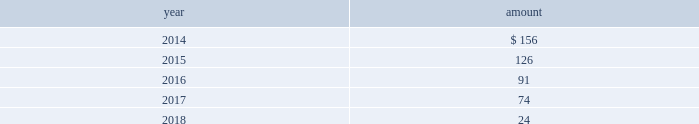The impairment tests performed for intangible assets as of july 31 , 2013 , 2012 and 2011 indicated no impairment charges were required .
Estimated amortization expense for finite-lived intangible assets for each of the five succeeding years is as follows : ( in millions ) .
Indefinite-lived acquired management contracts in july 2013 , in connection with the credit suisse etf transaction , the company acquired $ 231 million of indefinite-lived management contracts .
In march 2012 , in connection with the claymore transaction , the company acquired $ 163 million of indefinite-lived etp management contracts .
Finite-lived acquired management contracts in october 2013 , in connection with the mgpa transaction , the company acquired $ 29 million of finite-lived management contracts with a weighted-average estimated useful life of approximately eight years .
In september 2012 , in connection with the srpep transaction , the company acquired $ 40 million of finite- lived management contracts with a weighted-average estimated useful life of approximately 10 years .
11 .
Other assets at march 31 , 2013 , blackrock held an approximately one- third economic equity interest in private national mortgage acceptance company , llc ( 201cpnmac 201d ) , which is accounted for as an equity method investment and is included in other assets on the consolidated statements of financial condition .
On may 8 , 2013 , pennymac became the sole managing member of pnmac in connection with an initial public offering of pennymac ( the 201cpennymac ipo 201d ) .
As a result of the pennymac ipo , blackrock recorded a noncash , nonoperating pre-tax gain of $ 39 million related to the carrying value of its equity method investment .
Subsequent to the pennymac ipo , the company contributed 6.1 million units of its investment to a new donor advised fund ( the 201ccharitable contribution 201d ) .
The fair value of the charitable contribution was $ 124 million and is included in general and administration expenses on the consolidated statements of income .
In connection with the charitable contribution , the company also recorded a noncash , nonoperating pre-tax gain of $ 80 million related to the contributed investment and a tax benefit of approximately $ 48 million .
The carrying value and fair value of the company 2019s remaining interest ( approximately 20% ( 20 % ) or 16 million shares and units ) was approximately $ 127 million and $ 273 million , respectively , at december 31 , 2013 .
The fair value of the company 2019s interest reflected the pennymac stock price at december 31 , 2013 ( level 1 input ) .
12 .
Borrowings short-term borrowings the carrying value of short-term borrowings at december 31 , 2012 included $ 100 million under the 2012 revolving credit facility .
2013 revolving credit facility .
In march 2011 , the company entered into a five-year $ 3.5 billion unsecured revolving credit facility ( the 201c2011 credit facility 201d ) .
In march 2012 , the 2011 credit facility was amended to extend the maturity date by one year to march 2017 and in april 2012 the amount of the aggregate commitment was increased to $ 3.785 billion ( the 201c2012 credit facility 201d ) .
In march 2013 , the company 2019s credit facility was amended to extend the maturity date by one year to march 2018 and the amount of the aggregate commitment was increased to $ 3.990 billion ( the 201c2013 credit facility 201d ) .
The 2013 credit facility permits the company to request up to an additional $ 1.0 billion of borrowing capacity , subject to lender credit approval , increasing the overall size of the 2013 credit facility to an aggregate principal amount not to exceed $ 4.990 billion .
Interest on borrowings outstanding accrues at a rate based on the applicable london interbank offered rate plus a spread .
The 2013 credit facility requires the company not to exceed a maximum leverage ratio ( ratio of net debt to earnings before interest , taxes , depreciation and amortization , where net debt equals total debt less unrestricted cash ) of 3 to 1 , which was satisfied with a ratio of less than 1 to 1 at december 31 , 2013 .
The 2013 credit facility provides back- up liquidity , funds ongoing working capital for general corporate purposes and funds various investment opportunities .
At december 31 , 2013 , the company had no amount outstanding under the 2013 credit facility .
Commercial paper program .
On october 14 , 2009 , blackrock established a commercial paper program ( the 201ccp program 201d ) under which the company could issue unsecured commercial paper notes ( the 201ccp notes 201d ) on a private placement basis up to a maximum aggregate amount outstanding at any time of $ 3.0 billion .
On may 13 , 2011 , blackrock increased the maximum aggregate amount that may be borrowed under the cp program to $ 3.5 billion .
On may 17 , 2012 , blackrock increased the maximum aggregate amount to $ 3.785 billion .
In april 2013 , blackrock increased the maximum aggregate amount for which the company could issue unsecured cp notes on a private-placement basis up to a maximum aggregate amount outstanding at any time of $ 3.990 billion .
The commercial paper program is currently supported by the 2013 credit facility .
At december 31 , 2013 and 2012 , blackrock had no cp notes outstanding. .
What is the percent change in estimated amortization expense for finite-lived intangible assets from 2014 to 2015? 
Computations: ((156 - 126) / 126)
Answer: 0.2381. The impairment tests performed for intangible assets as of july 31 , 2013 , 2012 and 2011 indicated no impairment charges were required .
Estimated amortization expense for finite-lived intangible assets for each of the five succeeding years is as follows : ( in millions ) .
Indefinite-lived acquired management contracts in july 2013 , in connection with the credit suisse etf transaction , the company acquired $ 231 million of indefinite-lived management contracts .
In march 2012 , in connection with the claymore transaction , the company acquired $ 163 million of indefinite-lived etp management contracts .
Finite-lived acquired management contracts in october 2013 , in connection with the mgpa transaction , the company acquired $ 29 million of finite-lived management contracts with a weighted-average estimated useful life of approximately eight years .
In september 2012 , in connection with the srpep transaction , the company acquired $ 40 million of finite- lived management contracts with a weighted-average estimated useful life of approximately 10 years .
11 .
Other assets at march 31 , 2013 , blackrock held an approximately one- third economic equity interest in private national mortgage acceptance company , llc ( 201cpnmac 201d ) , which is accounted for as an equity method investment and is included in other assets on the consolidated statements of financial condition .
On may 8 , 2013 , pennymac became the sole managing member of pnmac in connection with an initial public offering of pennymac ( the 201cpennymac ipo 201d ) .
As a result of the pennymac ipo , blackrock recorded a noncash , nonoperating pre-tax gain of $ 39 million related to the carrying value of its equity method investment .
Subsequent to the pennymac ipo , the company contributed 6.1 million units of its investment to a new donor advised fund ( the 201ccharitable contribution 201d ) .
The fair value of the charitable contribution was $ 124 million and is included in general and administration expenses on the consolidated statements of income .
In connection with the charitable contribution , the company also recorded a noncash , nonoperating pre-tax gain of $ 80 million related to the contributed investment and a tax benefit of approximately $ 48 million .
The carrying value and fair value of the company 2019s remaining interest ( approximately 20% ( 20 % ) or 16 million shares and units ) was approximately $ 127 million and $ 273 million , respectively , at december 31 , 2013 .
The fair value of the company 2019s interest reflected the pennymac stock price at december 31 , 2013 ( level 1 input ) .
12 .
Borrowings short-term borrowings the carrying value of short-term borrowings at december 31 , 2012 included $ 100 million under the 2012 revolving credit facility .
2013 revolving credit facility .
In march 2011 , the company entered into a five-year $ 3.5 billion unsecured revolving credit facility ( the 201c2011 credit facility 201d ) .
In march 2012 , the 2011 credit facility was amended to extend the maturity date by one year to march 2017 and in april 2012 the amount of the aggregate commitment was increased to $ 3.785 billion ( the 201c2012 credit facility 201d ) .
In march 2013 , the company 2019s credit facility was amended to extend the maturity date by one year to march 2018 and the amount of the aggregate commitment was increased to $ 3.990 billion ( the 201c2013 credit facility 201d ) .
The 2013 credit facility permits the company to request up to an additional $ 1.0 billion of borrowing capacity , subject to lender credit approval , increasing the overall size of the 2013 credit facility to an aggregate principal amount not to exceed $ 4.990 billion .
Interest on borrowings outstanding accrues at a rate based on the applicable london interbank offered rate plus a spread .
The 2013 credit facility requires the company not to exceed a maximum leverage ratio ( ratio of net debt to earnings before interest , taxes , depreciation and amortization , where net debt equals total debt less unrestricted cash ) of 3 to 1 , which was satisfied with a ratio of less than 1 to 1 at december 31 , 2013 .
The 2013 credit facility provides back- up liquidity , funds ongoing working capital for general corporate purposes and funds various investment opportunities .
At december 31 , 2013 , the company had no amount outstanding under the 2013 credit facility .
Commercial paper program .
On october 14 , 2009 , blackrock established a commercial paper program ( the 201ccp program 201d ) under which the company could issue unsecured commercial paper notes ( the 201ccp notes 201d ) on a private placement basis up to a maximum aggregate amount outstanding at any time of $ 3.0 billion .
On may 13 , 2011 , blackrock increased the maximum aggregate amount that may be borrowed under the cp program to $ 3.5 billion .
On may 17 , 2012 , blackrock increased the maximum aggregate amount to $ 3.785 billion .
In april 2013 , blackrock increased the maximum aggregate amount for which the company could issue unsecured cp notes on a private-placement basis up to a maximum aggregate amount outstanding at any time of $ 3.990 billion .
The commercial paper program is currently supported by the 2013 credit facility .
At december 31 , 2013 and 2012 , blackrock had no cp notes outstanding. .
What is the tax benefit in connection with the charitable contribution as a percentage of the estimated amortization expense for finite-lived intangible assets in 2014? 
Computations: (48 / 156)
Answer: 0.30769. 